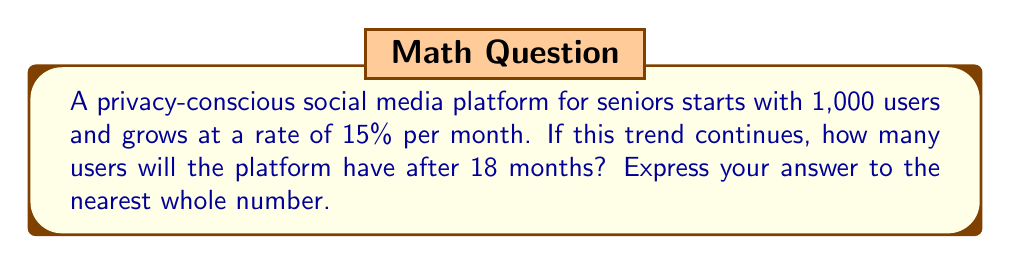Can you solve this math problem? Let's approach this step-by-step using an exponential growth function:

1) The general form of an exponential growth function is:
   $A(t) = A_0(1 + r)^t$
   
   Where:
   $A(t)$ is the amount after time $t$
   $A_0$ is the initial amount
   $r$ is the growth rate (as a decimal)
   $t$ is the time period

2) In this problem:
   $A_0 = 1,000$ (initial users)
   $r = 0.15$ (15% growth rate)
   $t = 18$ (months)

3) Plugging these values into our equation:
   $A(18) = 1000(1 + 0.15)^{18}$

4) Simplify:
   $A(18) = 1000(1.15)^{18}$

5) Calculate:
   $A(18) = 1000 * 11.0837...$
   $A(18) = 11,083.7...$

6) Rounding to the nearest whole number:
   $A(18) \approx 11,084$
Answer: 11,084 users 